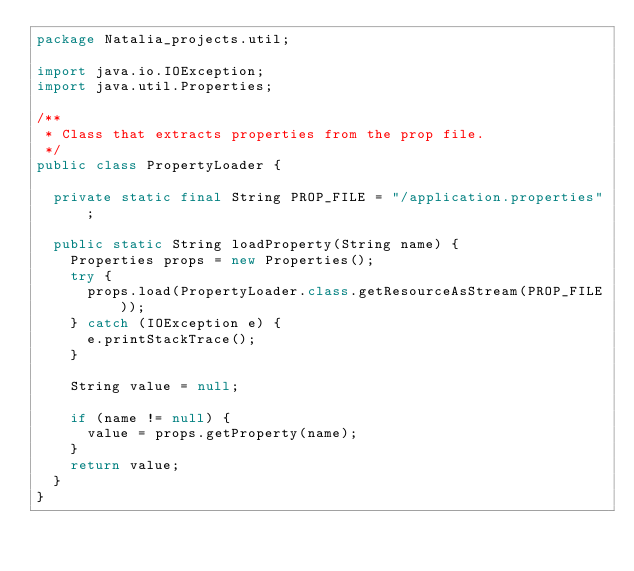Convert code to text. <code><loc_0><loc_0><loc_500><loc_500><_Java_>package Natalia_projects.util;

import java.io.IOException;
import java.util.Properties;

/**
 * Class that extracts properties from the prop file.
 */
public class PropertyLoader {

	private static final String PROP_FILE = "/application.properties";

	public static String loadProperty(String name) {
		Properties props = new Properties();
		try {
			props.load(PropertyLoader.class.getResourceAsStream(PROP_FILE));
		} catch (IOException e) {
			e.printStackTrace();
		}

		String value = null;

		if (name != null) {
			value = props.getProperty(name);
		}
		return value;
	}
}</code> 